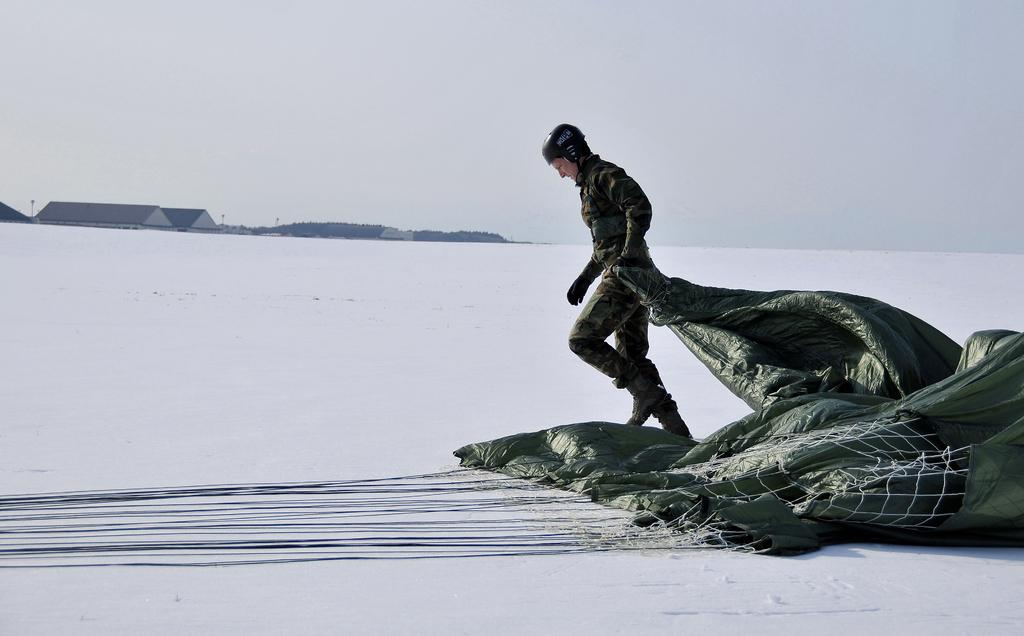What is the person in the image doing? The person is walking on the snow. What is the person holding in the image? The person is holding a green color object. What can be seen in the distance behind the person? There are houses visible in the background. What is the color of the sky in the image? The sky appears to be white in color. What type of cushion is being used by the person to walk on the snow? There is no cushion present in the image; the person is walking on the snow without any additional support. 